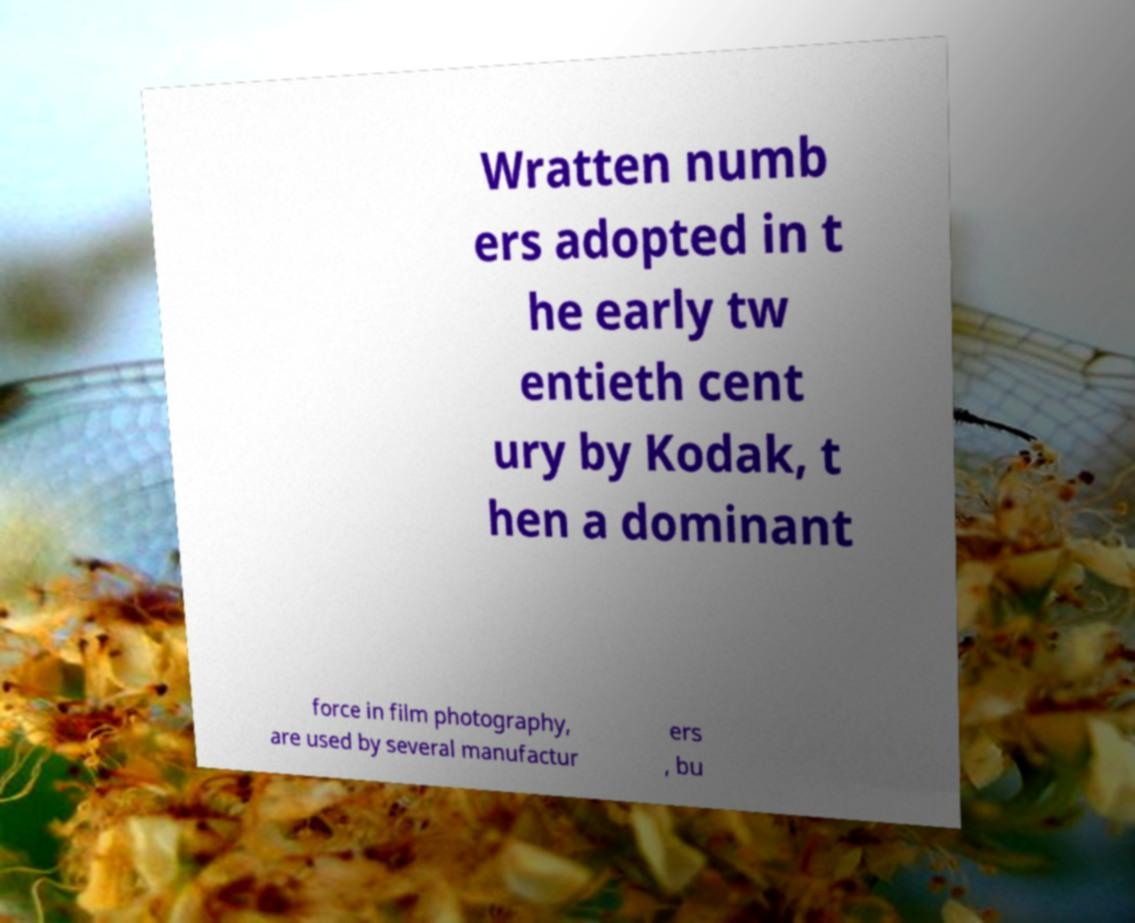Could you assist in decoding the text presented in this image and type it out clearly? Wratten numb ers adopted in t he early tw entieth cent ury by Kodak, t hen a dominant force in film photography, are used by several manufactur ers , bu 